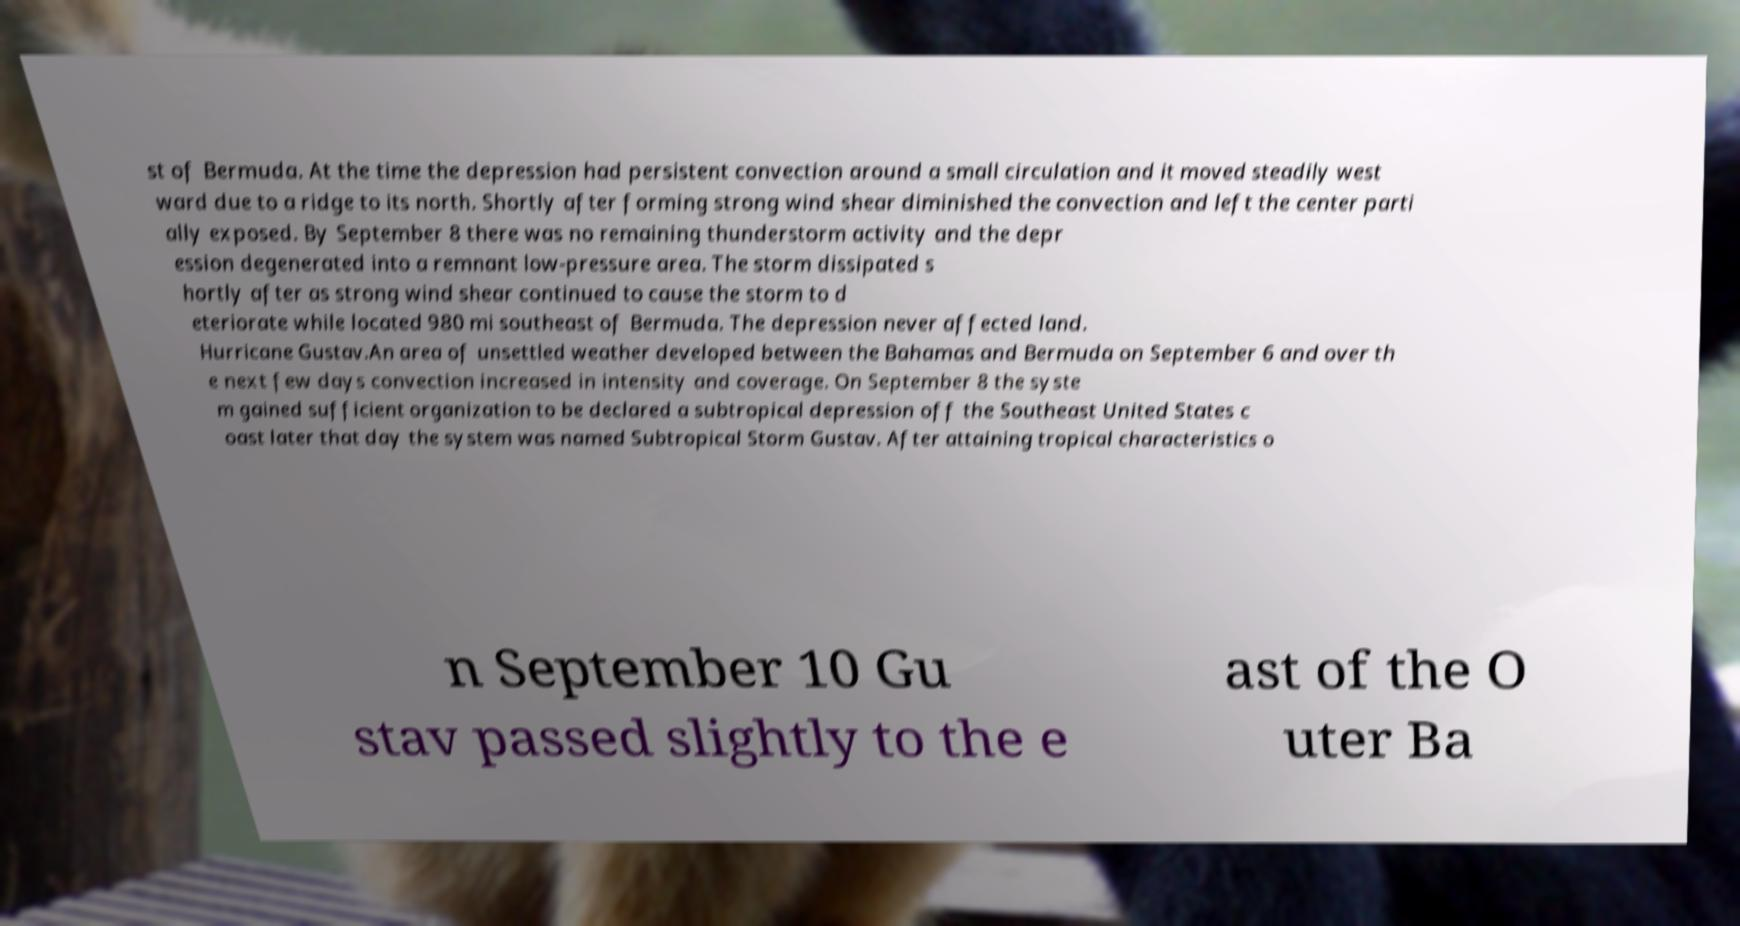Please read and relay the text visible in this image. What does it say? st of Bermuda. At the time the depression had persistent convection around a small circulation and it moved steadily west ward due to a ridge to its north. Shortly after forming strong wind shear diminished the convection and left the center parti ally exposed. By September 8 there was no remaining thunderstorm activity and the depr ession degenerated into a remnant low-pressure area. The storm dissipated s hortly after as strong wind shear continued to cause the storm to d eteriorate while located 980 mi southeast of Bermuda. The depression never affected land. Hurricane Gustav.An area of unsettled weather developed between the Bahamas and Bermuda on September 6 and over th e next few days convection increased in intensity and coverage. On September 8 the syste m gained sufficient organization to be declared a subtropical depression off the Southeast United States c oast later that day the system was named Subtropical Storm Gustav. After attaining tropical characteristics o n September 10 Gu stav passed slightly to the e ast of the O uter Ba 